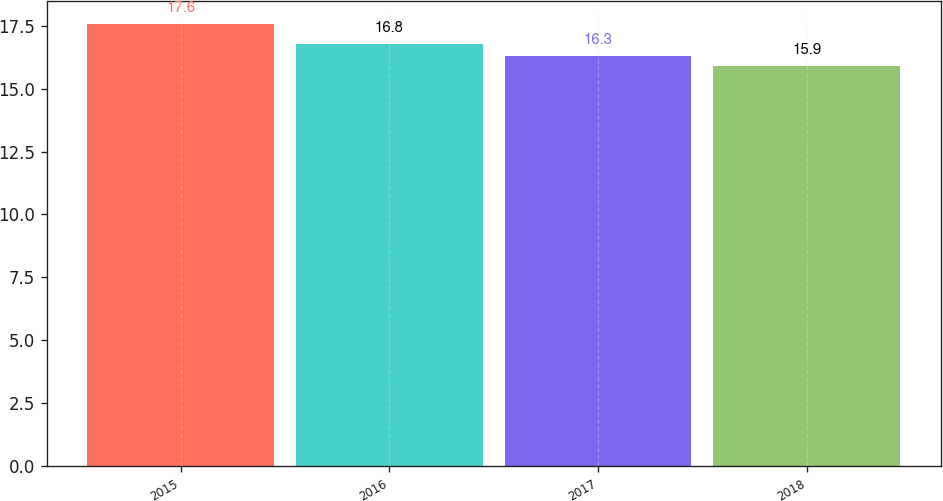Convert chart to OTSL. <chart><loc_0><loc_0><loc_500><loc_500><bar_chart><fcel>2015<fcel>2016<fcel>2017<fcel>2018<nl><fcel>17.6<fcel>16.8<fcel>16.3<fcel>15.9<nl></chart> 